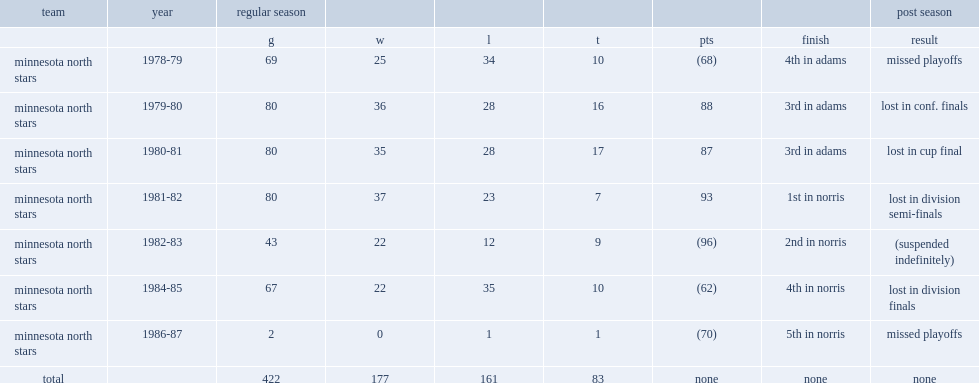How many games did glen sonmor appear for in 1986-87? 2.0. 